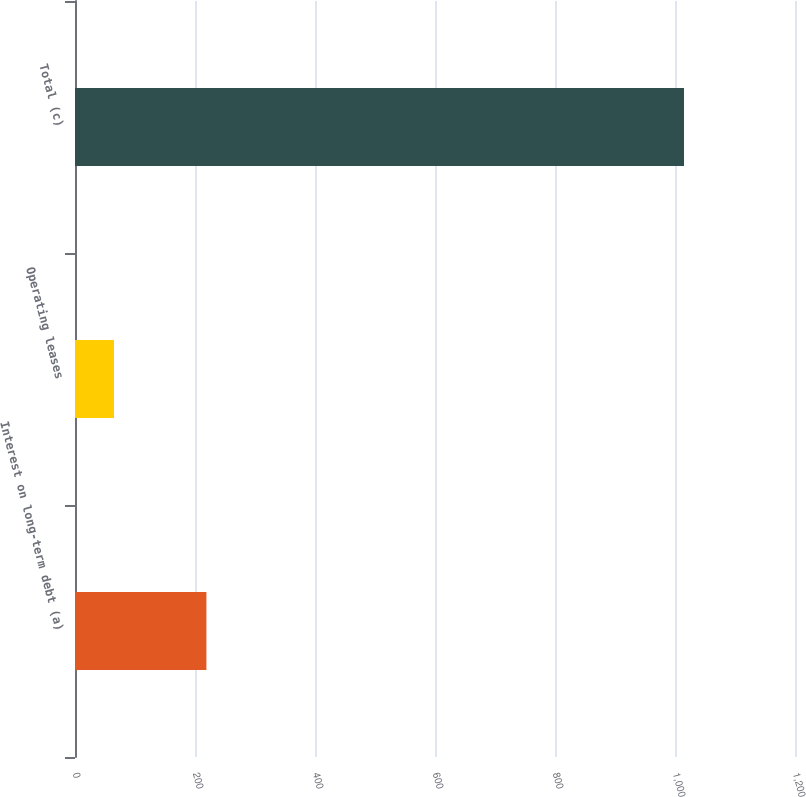<chart> <loc_0><loc_0><loc_500><loc_500><bar_chart><fcel>Interest on long-term debt (a)<fcel>Operating leases<fcel>Total (c)<nl><fcel>219<fcel>65<fcel>1015<nl></chart> 